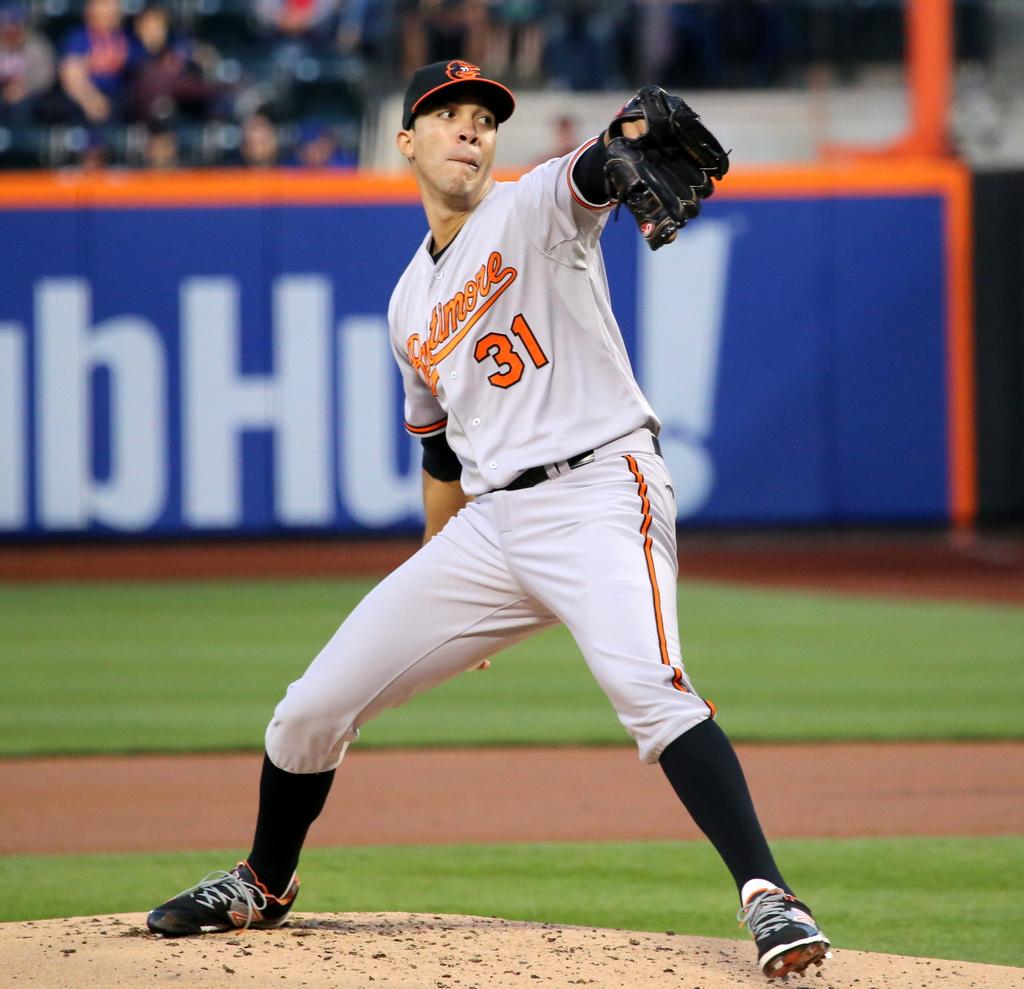What number is the pitcher?
Your answer should be very brief. 31. Which letter in the blue banner is capitalized?
Your answer should be compact. H. 